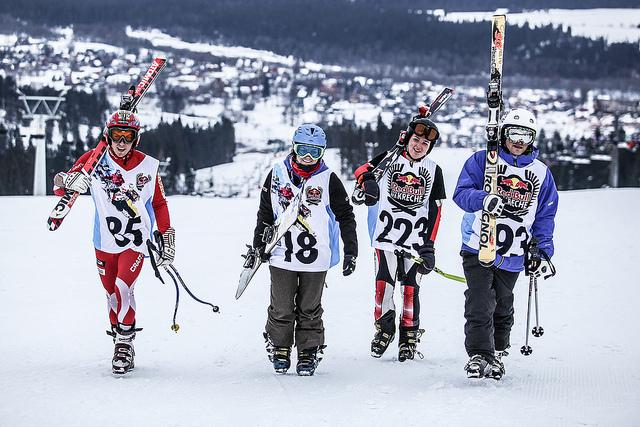How many of the 4 kids are holding skies? Please explain your reasoning. 3/4. There are 3 kids out of 4 who are holding skis. 